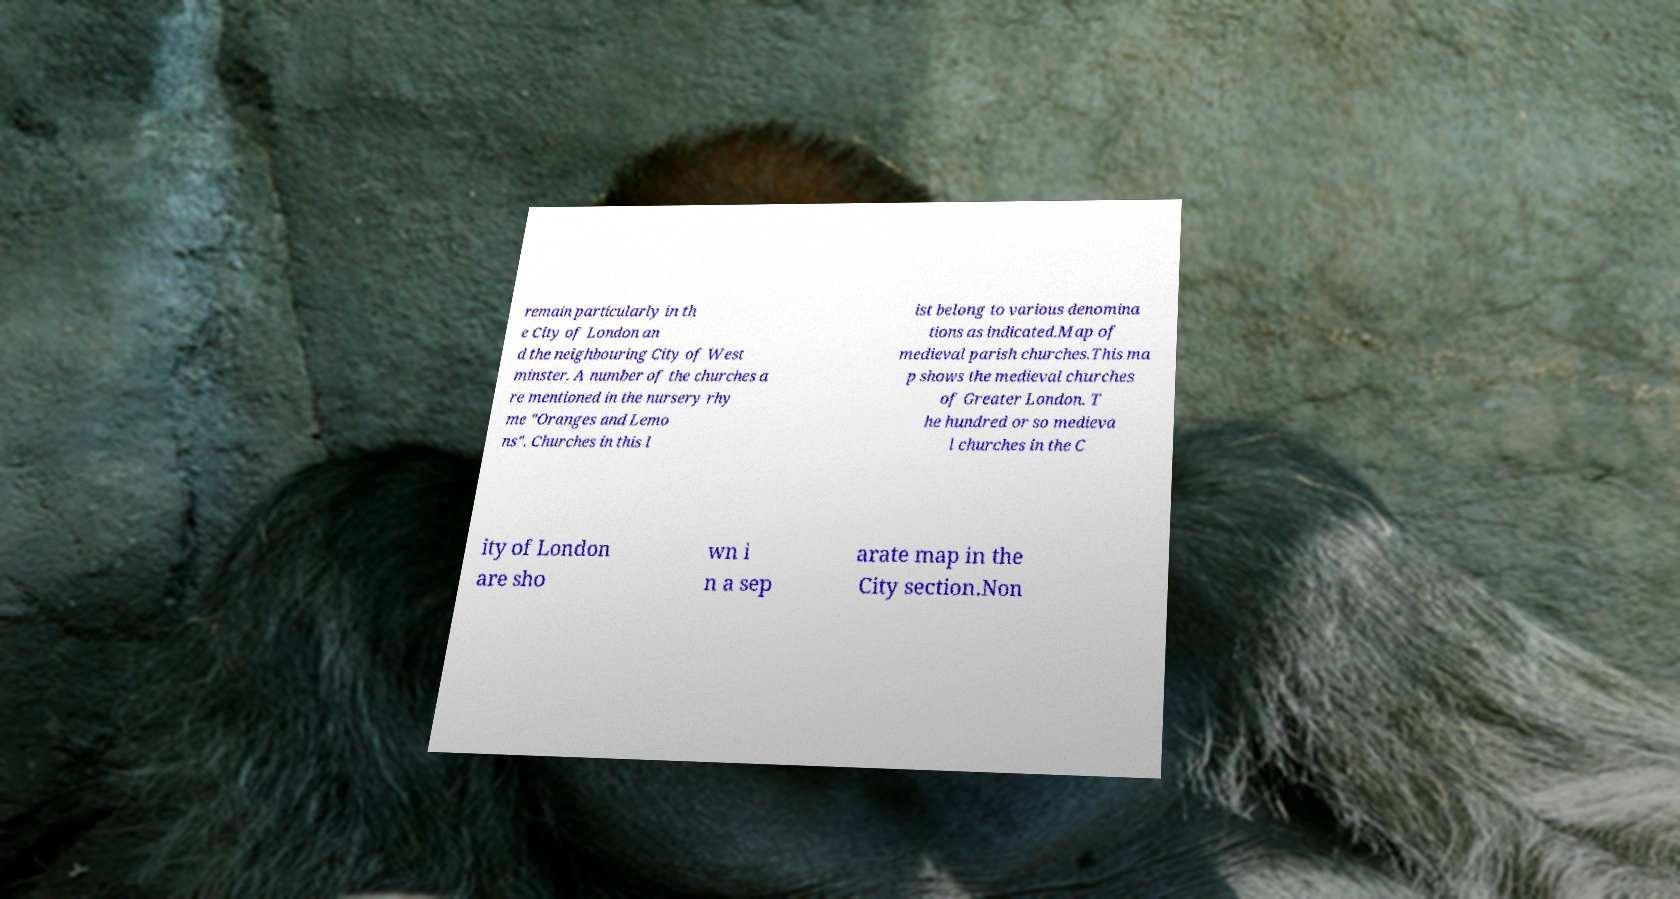Could you assist in decoding the text presented in this image and type it out clearly? remain particularly in th e City of London an d the neighbouring City of West minster. A number of the churches a re mentioned in the nursery rhy me "Oranges and Lemo ns". Churches in this l ist belong to various denomina tions as indicated.Map of medieval parish churches.This ma p shows the medieval churches of Greater London. T he hundred or so medieva l churches in the C ity of London are sho wn i n a sep arate map in the City section.Non 